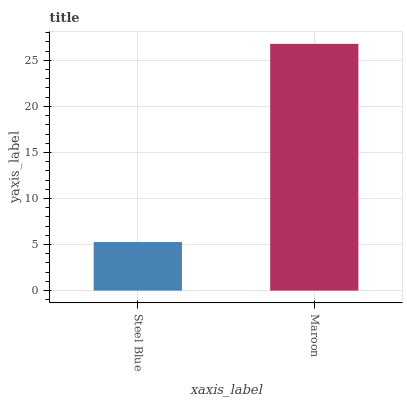Is Steel Blue the minimum?
Answer yes or no. Yes. Is Maroon the maximum?
Answer yes or no. Yes. Is Maroon the minimum?
Answer yes or no. No. Is Maroon greater than Steel Blue?
Answer yes or no. Yes. Is Steel Blue less than Maroon?
Answer yes or no. Yes. Is Steel Blue greater than Maroon?
Answer yes or no. No. Is Maroon less than Steel Blue?
Answer yes or no. No. Is Maroon the high median?
Answer yes or no. Yes. Is Steel Blue the low median?
Answer yes or no. Yes. Is Steel Blue the high median?
Answer yes or no. No. Is Maroon the low median?
Answer yes or no. No. 